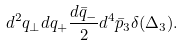<formula> <loc_0><loc_0><loc_500><loc_500>d ^ { 2 } q _ { \perp } d q _ { + } \frac { d { \bar { q } } _ { - } } { 2 } d ^ { 4 } { \bar { p } _ { 3 } } \delta ( \Delta _ { 3 } ) .</formula> 